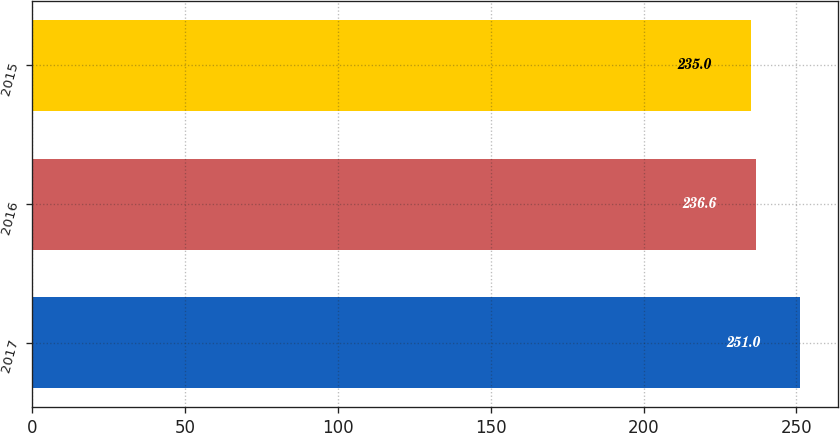Convert chart to OTSL. <chart><loc_0><loc_0><loc_500><loc_500><bar_chart><fcel>2017<fcel>2016<fcel>2015<nl><fcel>251<fcel>236.6<fcel>235<nl></chart> 